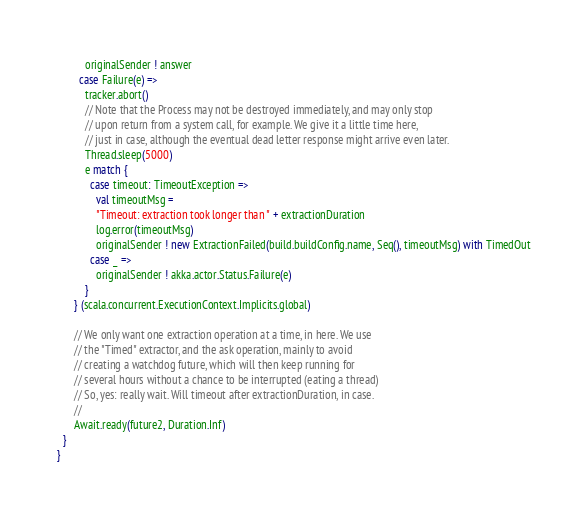Convert code to text. <code><loc_0><loc_0><loc_500><loc_500><_Scala_>          originalSender ! answer
        case Failure(e) =>
          tracker.abort()
          // Note that the Process may not be destroyed immediately, and may only stop
          // upon return from a system call, for example. We give it a little time here,
          // just in case, although the eventual dead letter response might arrive even later.
          Thread.sleep(5000)
          e match {
            case timeout: TimeoutException =>
              val timeoutMsg =
              "Timeout: extraction took longer than " + extractionDuration
              log.error(timeoutMsg)
              originalSender ! new ExtractionFailed(build.buildConfig.name, Seq(), timeoutMsg) with TimedOut
            case _ =>
              originalSender ! akka.actor.Status.Failure(e)
          }
      } (scala.concurrent.ExecutionContext.Implicits.global)

      // We only want one extraction operation at a time, in here. We use
      // the "Timed" extractor, and the ask operation, mainly to avoid
      // creating a watchdog future, which will then keep running for
      // several hours without a chance to be interrupted (eating a thread)
      // So, yes: really wait. Will timeout after extractionDuration, in case.
      //
      Await.ready(future2, Duration.Inf)
  }
}

</code> 